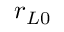Convert formula to latex. <formula><loc_0><loc_0><loc_500><loc_500>r _ { L 0 }</formula> 